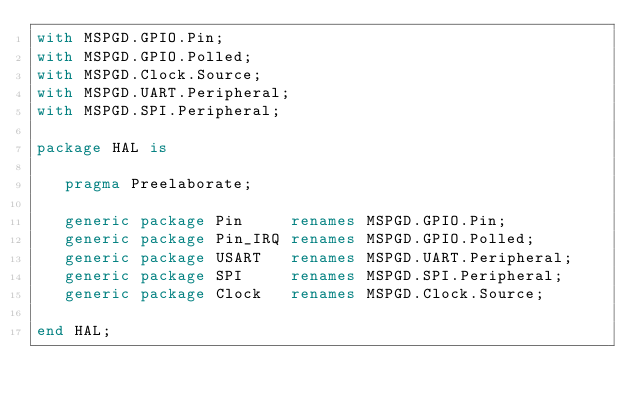<code> <loc_0><loc_0><loc_500><loc_500><_Ada_>with MSPGD.GPIO.Pin;
with MSPGD.GPIO.Polled;
with MSPGD.Clock.Source;
with MSPGD.UART.Peripheral;
with MSPGD.SPI.Peripheral;

package HAL is

   pragma Preelaborate;

   generic package Pin     renames MSPGD.GPIO.Pin;
   generic package Pin_IRQ renames MSPGD.GPIO.Polled;
   generic package USART   renames MSPGD.UART.Peripheral;
   generic package SPI     renames MSPGD.SPI.Peripheral;
   generic package Clock   renames MSPGD.Clock.Source;

end HAL;
</code> 